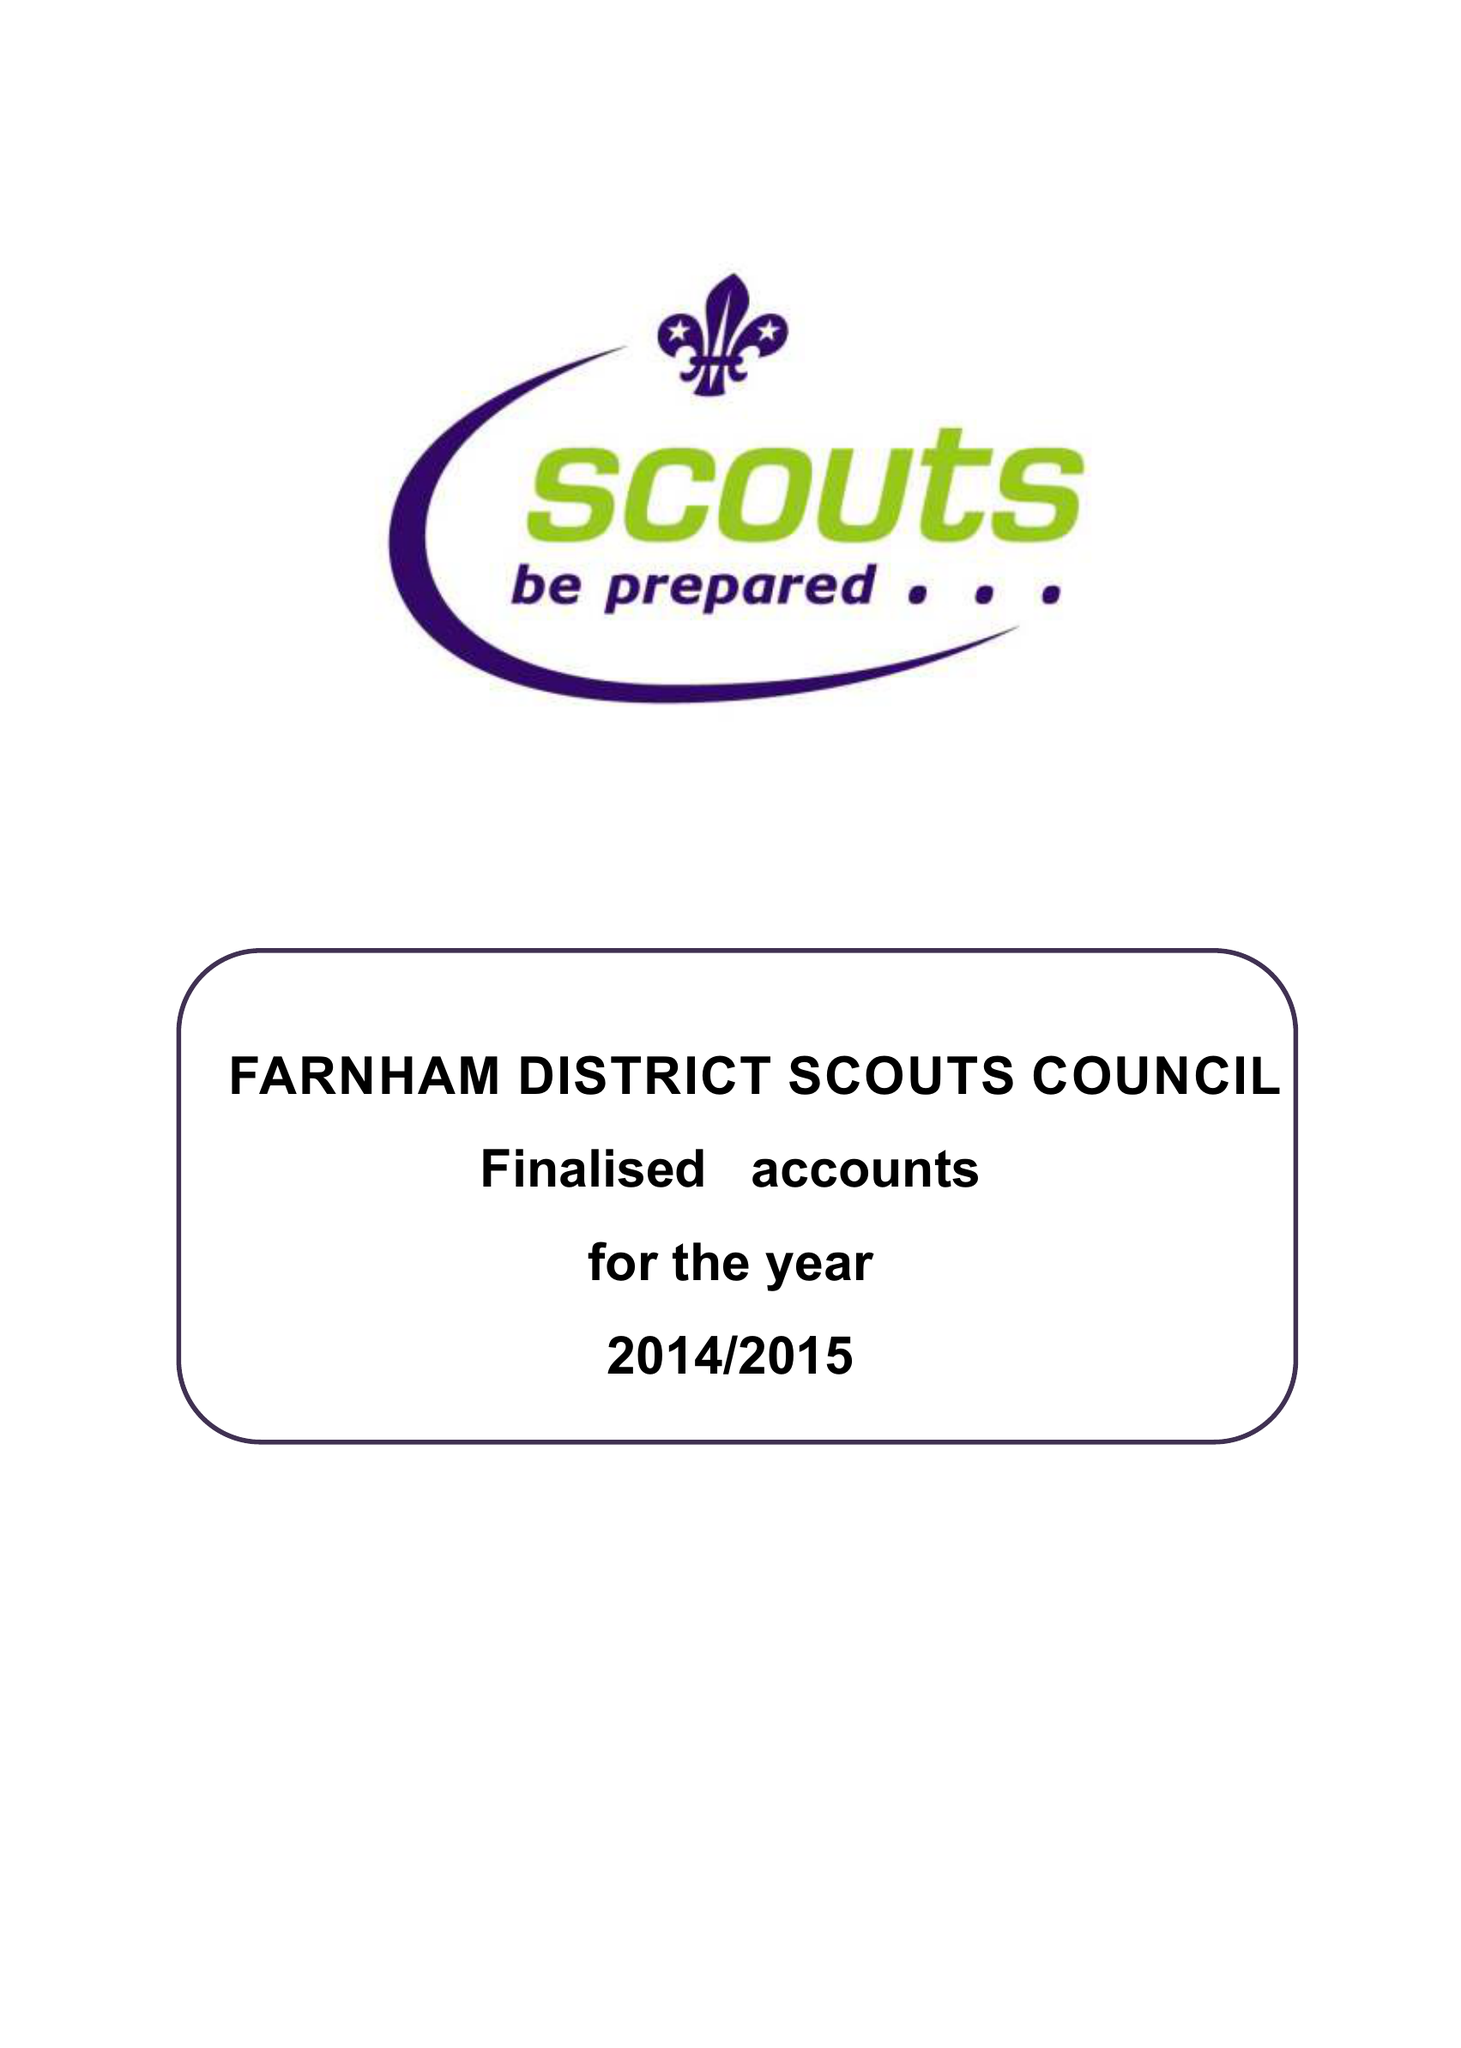What is the value for the income_annually_in_british_pounds?
Answer the question using a single word or phrase. 105571.00 